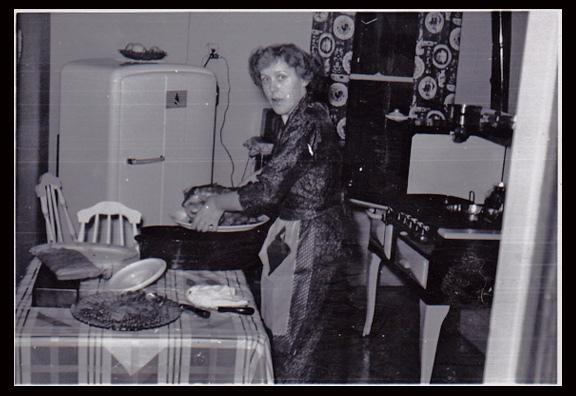What type of region is this likely? Please explain your reasoning. city. Looks to be a smaller kitchen that is probably in a city house or apartment. 